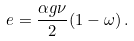<formula> <loc_0><loc_0><loc_500><loc_500>e = \frac { \alpha g \nu } { 2 } ( 1 - \omega ) \, .</formula> 